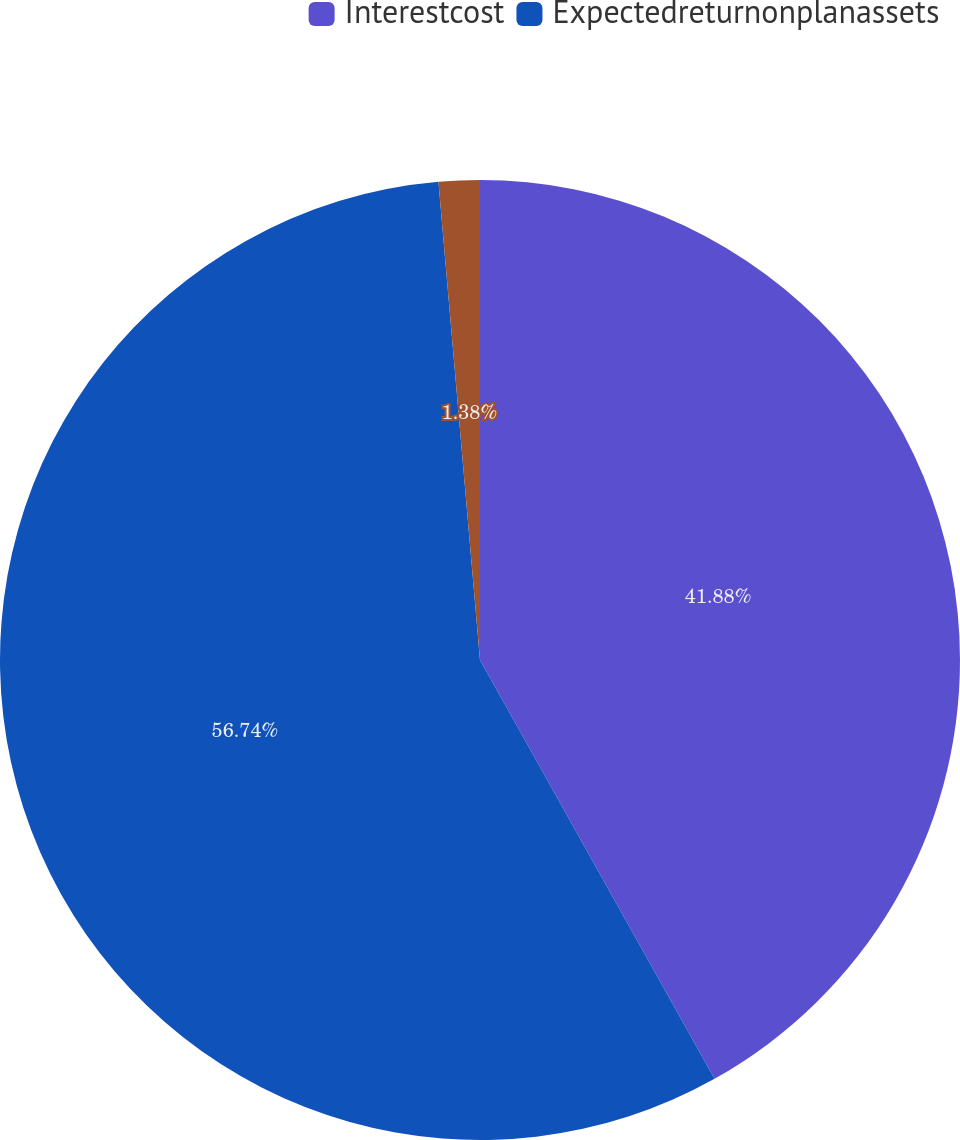<chart> <loc_0><loc_0><loc_500><loc_500><pie_chart><fcel>Interestcost<fcel>Expectedreturnonplanassets<fcel>Unnamed: 2<nl><fcel>41.88%<fcel>56.75%<fcel>1.38%<nl></chart> 